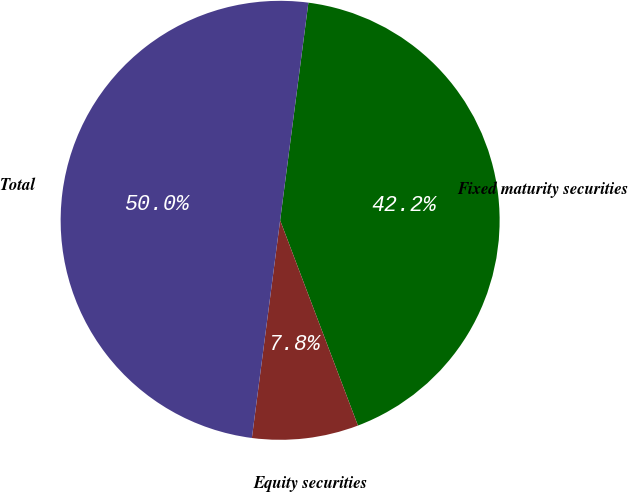Convert chart. <chart><loc_0><loc_0><loc_500><loc_500><pie_chart><fcel>Fixed maturity securities<fcel>Equity securities<fcel>Total<nl><fcel>42.18%<fcel>7.82%<fcel>50.0%<nl></chart> 